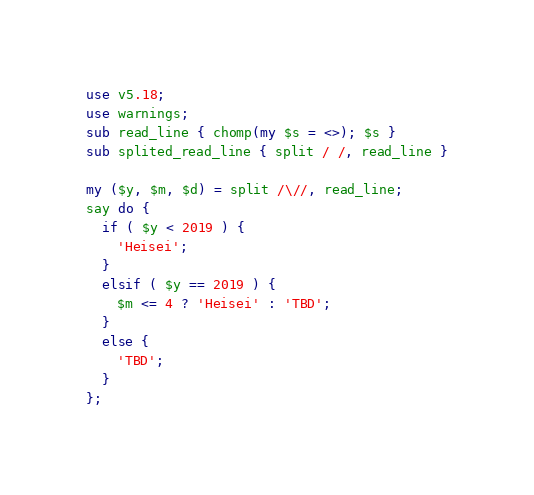<code> <loc_0><loc_0><loc_500><loc_500><_Perl_>use v5.18;
use warnings;
sub read_line { chomp(my $s = <>); $s }
sub splited_read_line { split / /, read_line }

my ($y, $m, $d) = split /\//, read_line;
say do {
  if ( $y < 2019 ) {
    'Heisei';
  }
  elsif ( $y == 2019 ) {
    $m <= 4 ? 'Heisei' : 'TBD';
  }
  else {
    'TBD';
  }
};
</code> 